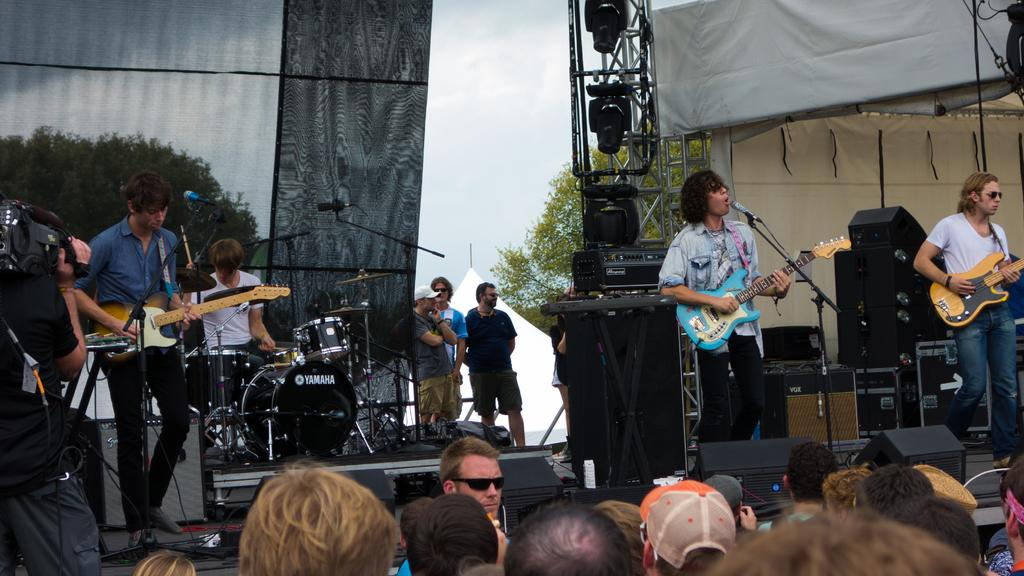How many people are in the group shown in the image? There is a group of people in the image, but the exact number is not specified. What are some of the people in the group doing? Some people in the group are playing musical instruments. What can be seen in the background of the image? There is a tree visible in the background of the image. What type of card is being used to divide the group in the image? There is no card present in the image, and the group is not being divided by any means. 